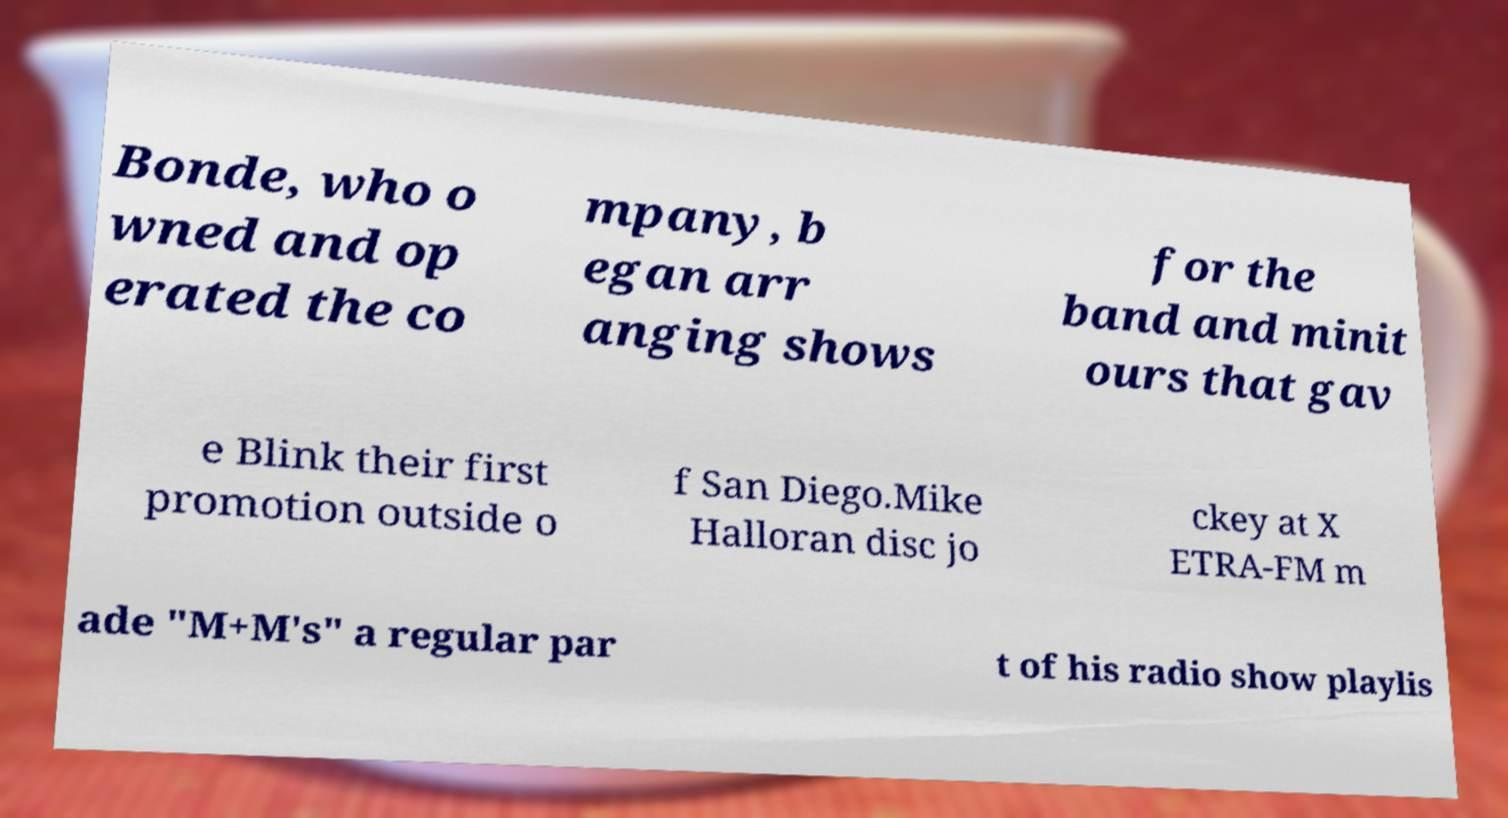What messages or text are displayed in this image? I need them in a readable, typed format. Bonde, who o wned and op erated the co mpany, b egan arr anging shows for the band and minit ours that gav e Blink their first promotion outside o f San Diego.Mike Halloran disc jo ckey at X ETRA-FM m ade "M+M's" a regular par t of his radio show playlis 